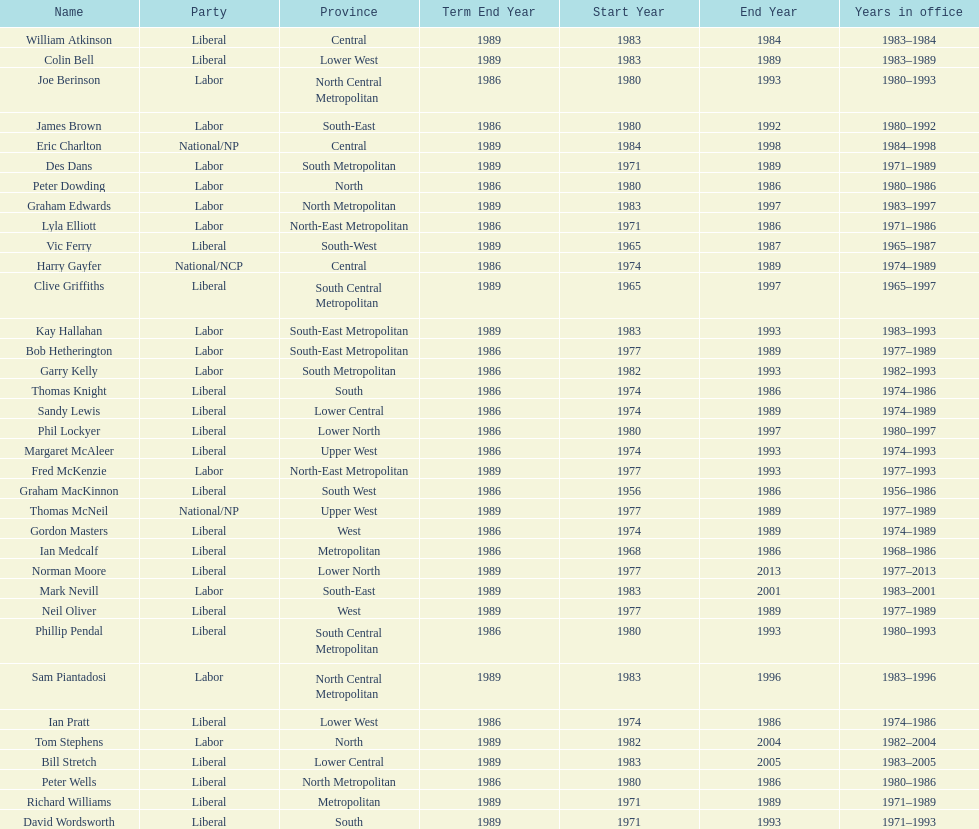Hame the last member listed whose last name begins with "p". Ian Pratt. Can you parse all the data within this table? {'header': ['Name', 'Party', 'Province', 'Term End Year', 'Start Year', 'End Year', 'Years in office'], 'rows': [['William Atkinson', 'Liberal', 'Central', '1989', '1983', '1984', '1983–1984'], ['Colin Bell', 'Liberal', 'Lower West', '1989', '1983', '1989', '1983–1989'], ['Joe Berinson', 'Labor', 'North Central Metropolitan', '1986', '1980', '1993', '1980–1993'], ['James Brown', 'Labor', 'South-East', '1986', '1980', '1992', '1980–1992'], ['Eric Charlton', 'National/NP', 'Central', '1989', '1984', '1998', '1984–1998'], ['Des Dans', 'Labor', 'South Metropolitan', '1989', '1971', '1989', '1971–1989'], ['Peter Dowding', 'Labor', 'North', '1986', '1980', '1986', '1980–1986'], ['Graham Edwards', 'Labor', 'North Metropolitan', '1989', '1983', '1997', '1983–1997'], ['Lyla Elliott', 'Labor', 'North-East Metropolitan', '1986', '1971', '1986', '1971–1986'], ['Vic Ferry', 'Liberal', 'South-West', '1989', '1965', '1987', '1965–1987'], ['Harry Gayfer', 'National/NCP', 'Central', '1986', '1974', '1989', '1974–1989'], ['Clive Griffiths', 'Liberal', 'South Central Metropolitan', '1989', '1965', '1997', '1965–1997'], ['Kay Hallahan', 'Labor', 'South-East Metropolitan', '1989', '1983', '1993', '1983–1993'], ['Bob Hetherington', 'Labor', 'South-East Metropolitan', '1986', '1977', '1989', '1977–1989'], ['Garry Kelly', 'Labor', 'South Metropolitan', '1986', '1982', '1993', '1982–1993'], ['Thomas Knight', 'Liberal', 'South', '1986', '1974', '1986', '1974–1986'], ['Sandy Lewis', 'Liberal', 'Lower Central', '1986', '1974', '1989', '1974–1989'], ['Phil Lockyer', 'Liberal', 'Lower North', '1986', '1980', '1997', '1980–1997'], ['Margaret McAleer', 'Liberal', 'Upper West', '1986', '1974', '1993', '1974–1993'], ['Fred McKenzie', 'Labor', 'North-East Metropolitan', '1989', '1977', '1993', '1977–1993'], ['Graham MacKinnon', 'Liberal', 'South West', '1986', '1956', '1986', '1956–1986'], ['Thomas McNeil', 'National/NP', 'Upper West', '1989', '1977', '1989', '1977–1989'], ['Gordon Masters', 'Liberal', 'West', '1986', '1974', '1989', '1974–1989'], ['Ian Medcalf', 'Liberal', 'Metropolitan', '1986', '1968', '1986', '1968–1986'], ['Norman Moore', 'Liberal', 'Lower North', '1989', '1977', '2013', '1977–2013'], ['Mark Nevill', 'Labor', 'South-East', '1989', '1983', '2001', '1983–2001'], ['Neil Oliver', 'Liberal', 'West', '1989', '1977', '1989', '1977–1989'], ['Phillip Pendal', 'Liberal', 'South Central Metropolitan', '1986', '1980', '1993', '1980–1993'], ['Sam Piantadosi', 'Labor', 'North Central Metropolitan', '1989', '1983', '1996', '1983–1996'], ['Ian Pratt', 'Liberal', 'Lower West', '1986', '1974', '1986', '1974–1986'], ['Tom Stephens', 'Labor', 'North', '1989', '1982', '2004', '1982–2004'], ['Bill Stretch', 'Liberal', 'Lower Central', '1989', '1983', '2005', '1983–2005'], ['Peter Wells', 'Liberal', 'North Metropolitan', '1986', '1980', '1986', '1980–1986'], ['Richard Williams', 'Liberal', 'Metropolitan', '1989', '1971', '1989', '1971–1989'], ['David Wordsworth', 'Liberal', 'South', '1989', '1971', '1993', '1971–1993']]} 